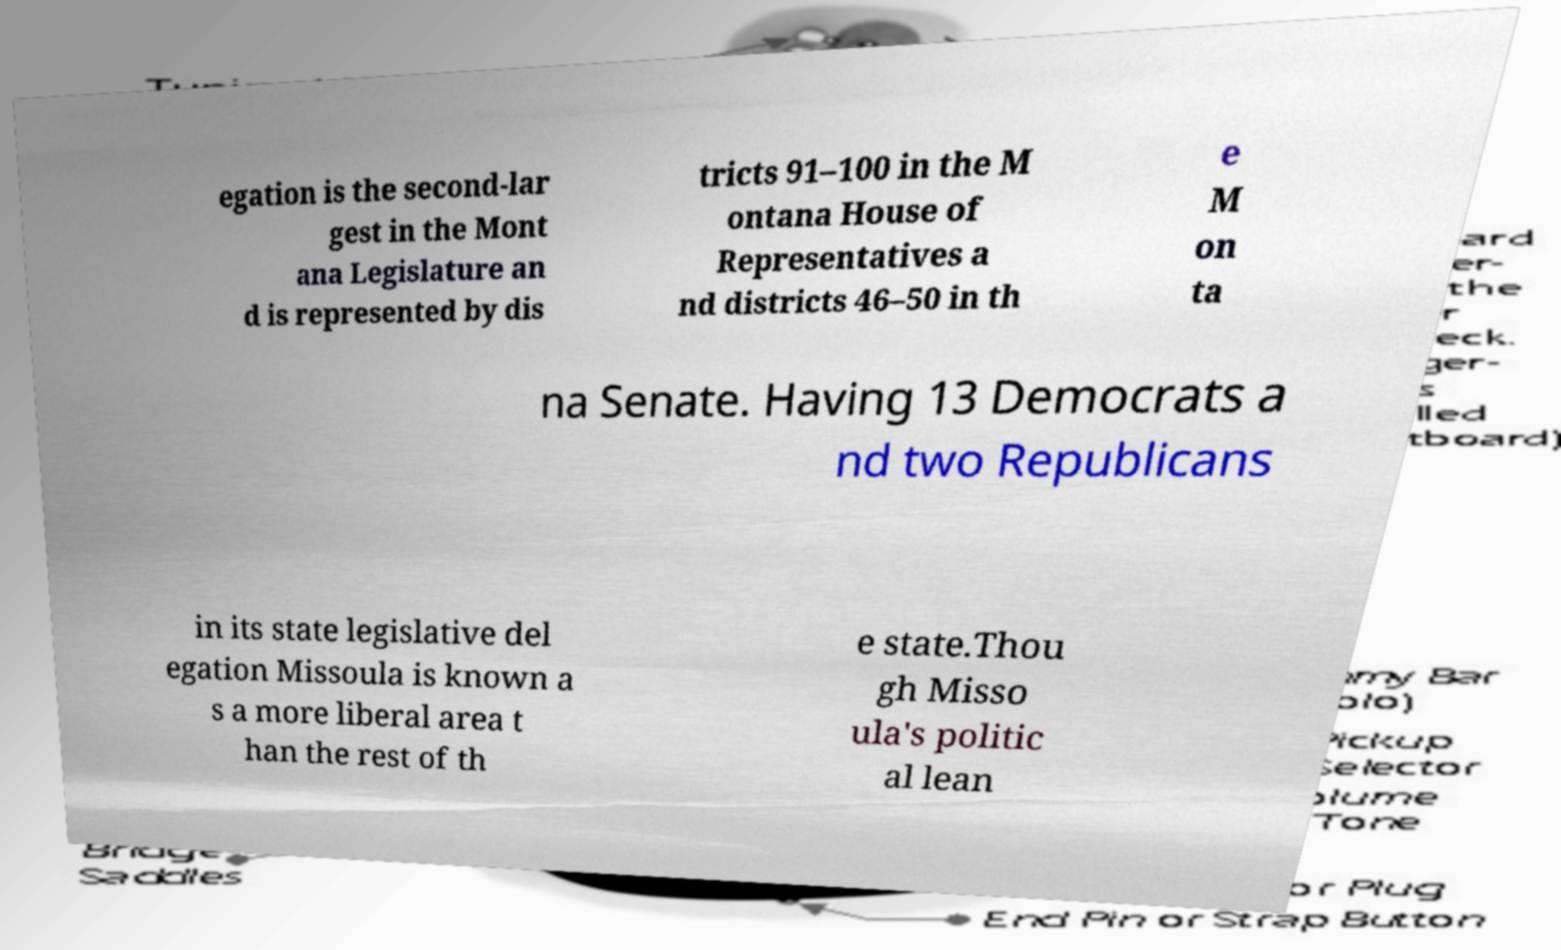There's text embedded in this image that I need extracted. Can you transcribe it verbatim? egation is the second-lar gest in the Mont ana Legislature an d is represented by dis tricts 91–100 in the M ontana House of Representatives a nd districts 46–50 in th e M on ta na Senate. Having 13 Democrats a nd two Republicans in its state legislative del egation Missoula is known a s a more liberal area t han the rest of th e state.Thou gh Misso ula's politic al lean 